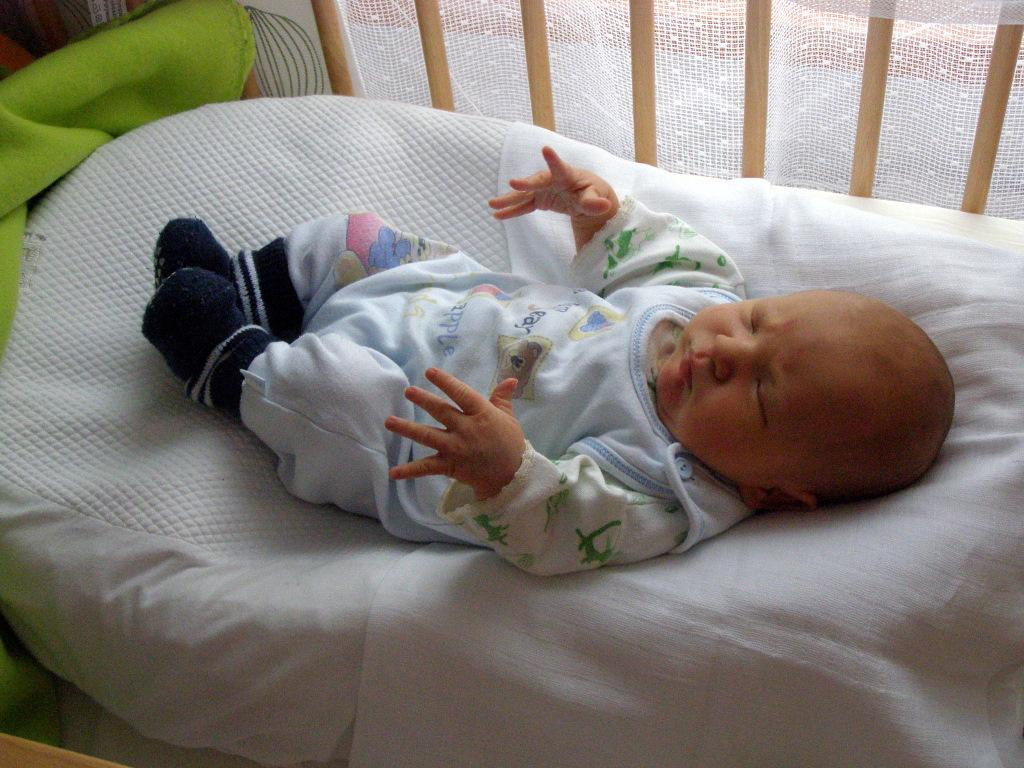What is the main subject of the image? There is a small baby in the image. What is the baby doing in the image? The baby is sleeping. Where is the baby located in the image? The baby is in a cot bed. What can be seen behind the cot bed in the image? There is a white color net behind the cot bed. What type of quicksand can be seen surrounding the baby's cot bed in the image? There is no quicksand present in the image; the baby is safely in a cot bed with a white color net behind it. 